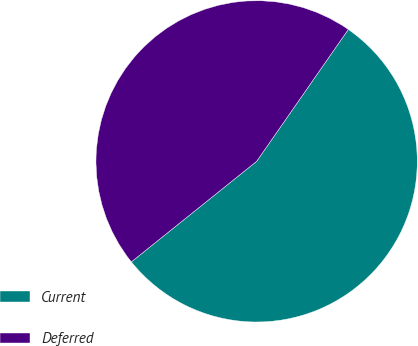<chart> <loc_0><loc_0><loc_500><loc_500><pie_chart><fcel>Current<fcel>Deferred<nl><fcel>54.57%<fcel>45.43%<nl></chart> 